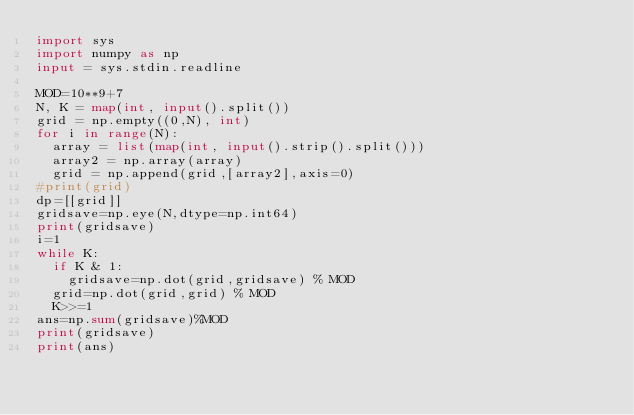Convert code to text. <code><loc_0><loc_0><loc_500><loc_500><_Python_>import sys
import numpy as np
input = sys.stdin.readline

MOD=10**9+7
N, K = map(int, input().split())
grid = np.empty((0,N), int)
for i in range(N):
  array = list(map(int, input().strip().split()))
  array2 = np.array(array)
  grid = np.append(grid,[array2],axis=0)
#print(grid)
dp=[[grid]]
gridsave=np.eye(N,dtype=np.int64)
print(gridsave)
i=1
while K:
  if K & 1:
    gridsave=np.dot(grid,gridsave) % MOD
  grid=np.dot(grid,grid) % MOD
  K>>=1
ans=np.sum(gridsave)%MOD
print(gridsave)
print(ans)</code> 